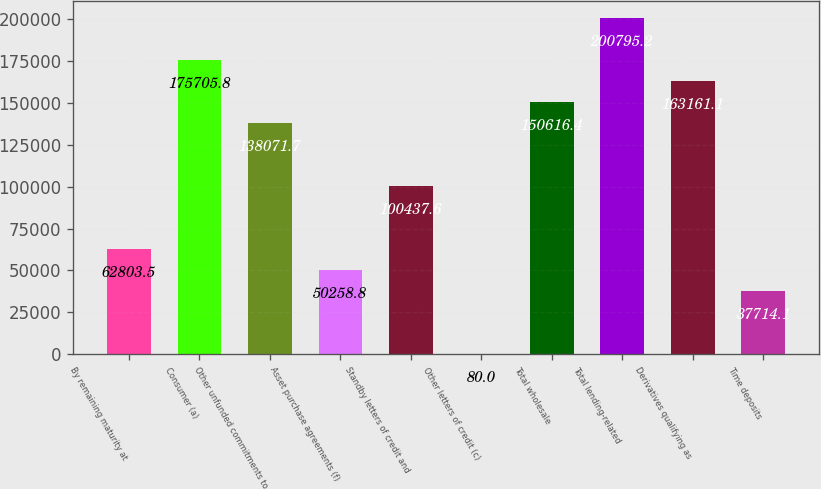Convert chart to OTSL. <chart><loc_0><loc_0><loc_500><loc_500><bar_chart><fcel>By remaining maturity at<fcel>Consumer (a)<fcel>Other unfunded commitments to<fcel>Asset purchase agreements (f)<fcel>Standby letters of credit and<fcel>Other letters of credit (c)<fcel>Total wholesale<fcel>Total lending-related<fcel>Derivatives qualifying as<fcel>Time deposits<nl><fcel>62803.5<fcel>175706<fcel>138072<fcel>50258.8<fcel>100438<fcel>80<fcel>150616<fcel>200795<fcel>163161<fcel>37714.1<nl></chart> 